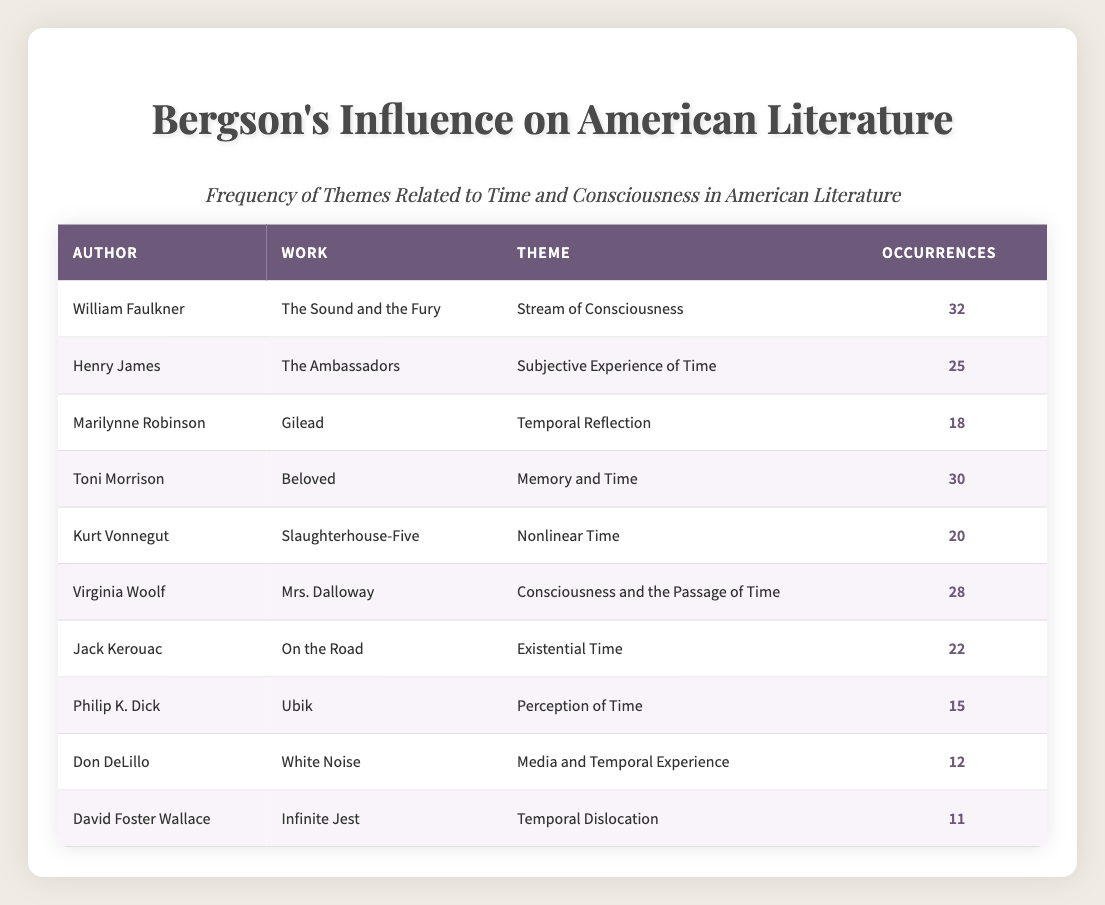What is the total number of occurrences of the theme "Stream of Consciousness"? The theme "Stream of Consciousness" is found in William Faulkner's "The Sound and the Fury," which has 32 occurrences, so the total number for this theme is directly taken from the table.
Answer: 32 Who authored "Beloved"? "Beloved" is listed under Toni Morrison in the "Work" column of the table. Thus, the author of "Beloved" is found directly in the corresponding row.
Answer: Toni Morrison Which theme has the highest number of occurrences? By comparing the occurrences listed, "Stream of Consciousness" has 32 occurrences, while other themes like "Memory and Time" and "Consciousness and the Passage of Time" have lower counts (30 and 28, respectively). Therefore, the theme with the highest occurrences is "Stream of Consciousness."
Answer: Stream of Consciousness What is the sum of occurrences for the themes "Memory and Time" and "Temporal Reflection"? The occurrences for "Memory and Time" (30) and "Temporal Reflection" (18) are summed up to find their total. 30 + 18 = 48 gives the cumulative occurrences for these themes.
Answer: 48 Is "Nonlinear Time" found more than 20 times in American literature according to the table? The occurrences for "Nonlinear Time" are listed at 20, which is not greater than 20 but equal to it, so the answer to whether it is found more than 20 times is no.
Answer: No If we consider the theme "Perception of Time," how many occurrences do other themes exceed it? "Perception of Time" has 15 occurrences. Looking at the table, the themes with occurrences exceeding 15 are: "Stream of Consciousness" (32), "Memory and Time" (30), "Consciousness and the Passage of Time" (28), "Toni Morrison" (30), "Existential Time" (22), and "Nonlinear Time" (20). Counting these themes gives us a total of 6 themes that exceed 15 occurrences.
Answer: 6 Which author appears with the least number of occurrences in the table? By scanning the occurrences from the table, we can see that "Infinite Jest" by David Foster Wallace has the lowest count with 11 occurrences, making him the author with the least number of occurrences.
Answer: David Foster Wallace What percentage of total occurrences does "Temporal Dislocation" represent? To find this percentage, first, calculate the total occurrences from each theme and then take "Temporal Dislocation" (11 occurrences) as a fraction of that total. The total occurrences are (32 + 25 + 18 + 30 + 20 + 28 + 22 + 15 + 12 + 11) =  298. Now, divide 11 by 298 and multiply by 100 to get the percentage: (11 / 298) * 100 ≈ 3.69%. Therefore, "Temporal Dislocation" represents approximately 3.69% of total occurrences.
Answer: 3.69% 